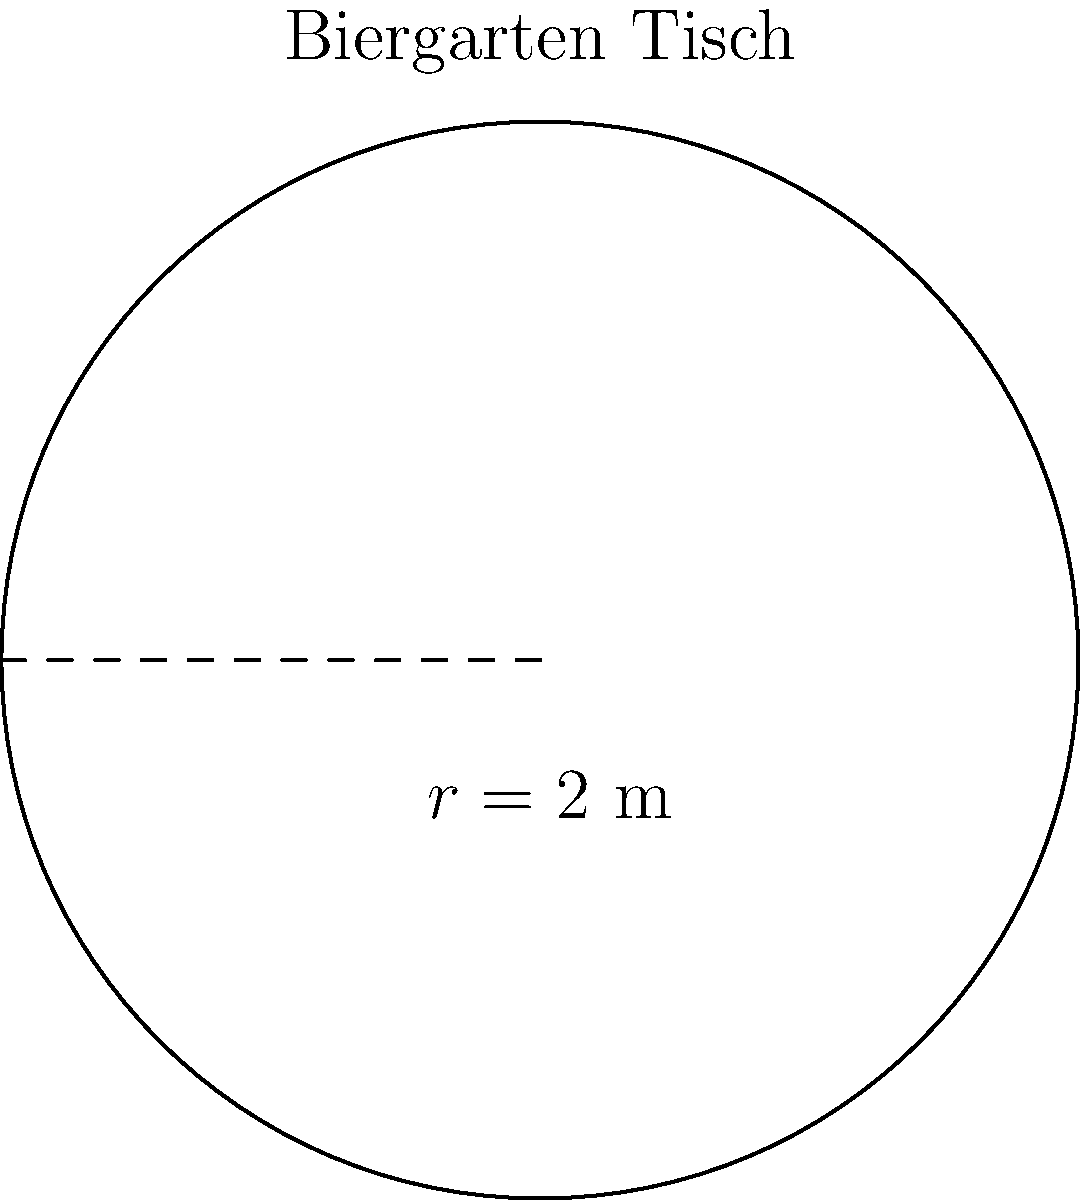In einem gemütlichen Biergarten möchten Sie die Fläche eines runden Tisches berechnen. Der Radius des Tisches beträgt 2 Meter. Wie groß ist die Fläche des Tisches in Quadratmetern? Runden Sie Ihr Ergebnis auf zwei Dezimalstellen. Um die Fläche eines kreisförmigen Tisches zu berechnen, verwenden wir die Formel für die Kreisfläche:

$$A = \pi r^2$$

Wobei:
$A$ = Fläche des Kreises
$\pi$ = Pi (etwa 3,14159)
$r$ = Radius des Kreises

Gegeben ist:
$r = 2$ Meter

Einsetzen der Werte in die Formel:

$$A = \pi \cdot 2^2$$
$$A = \pi \cdot 4$$
$$A \approx 3,14159 \cdot 4$$
$$A \approx 12,56636$$

Gerundet auf zwei Dezimalstellen:

$$A \approx 12,57 \text{ m}^2$$
Answer: $12,57 \text{ m}^2$ 